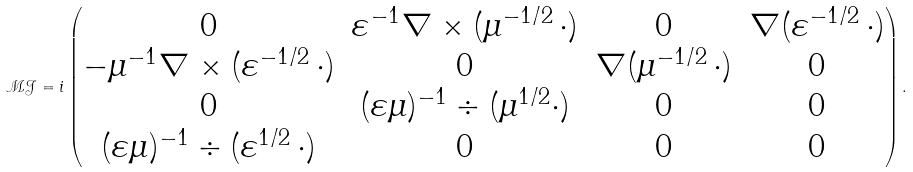Convert formula to latex. <formula><loc_0><loc_0><loc_500><loc_500>\mathcal { M } \mathcal { J } = i \begin{pmatrix} 0 & \varepsilon ^ { - 1 } \nabla \times ( \mu ^ { - 1 / 2 } \, \cdot ) & 0 & \nabla ( \varepsilon ^ { - 1 / 2 } \, \cdot ) \\ - \mu ^ { - 1 } \nabla \times ( \varepsilon ^ { - 1 / 2 } \, \cdot ) & 0 & \nabla ( \mu ^ { - 1 / 2 } \, \cdot ) & 0 \\ 0 & ( \varepsilon \mu ) ^ { - 1 } \div ( \mu ^ { 1 / 2 } \cdot ) & 0 & 0 \\ ( \varepsilon \mu ) ^ { - 1 } \div ( \varepsilon ^ { 1 / 2 } \, \cdot ) & 0 & 0 & 0 \end{pmatrix} .</formula> 